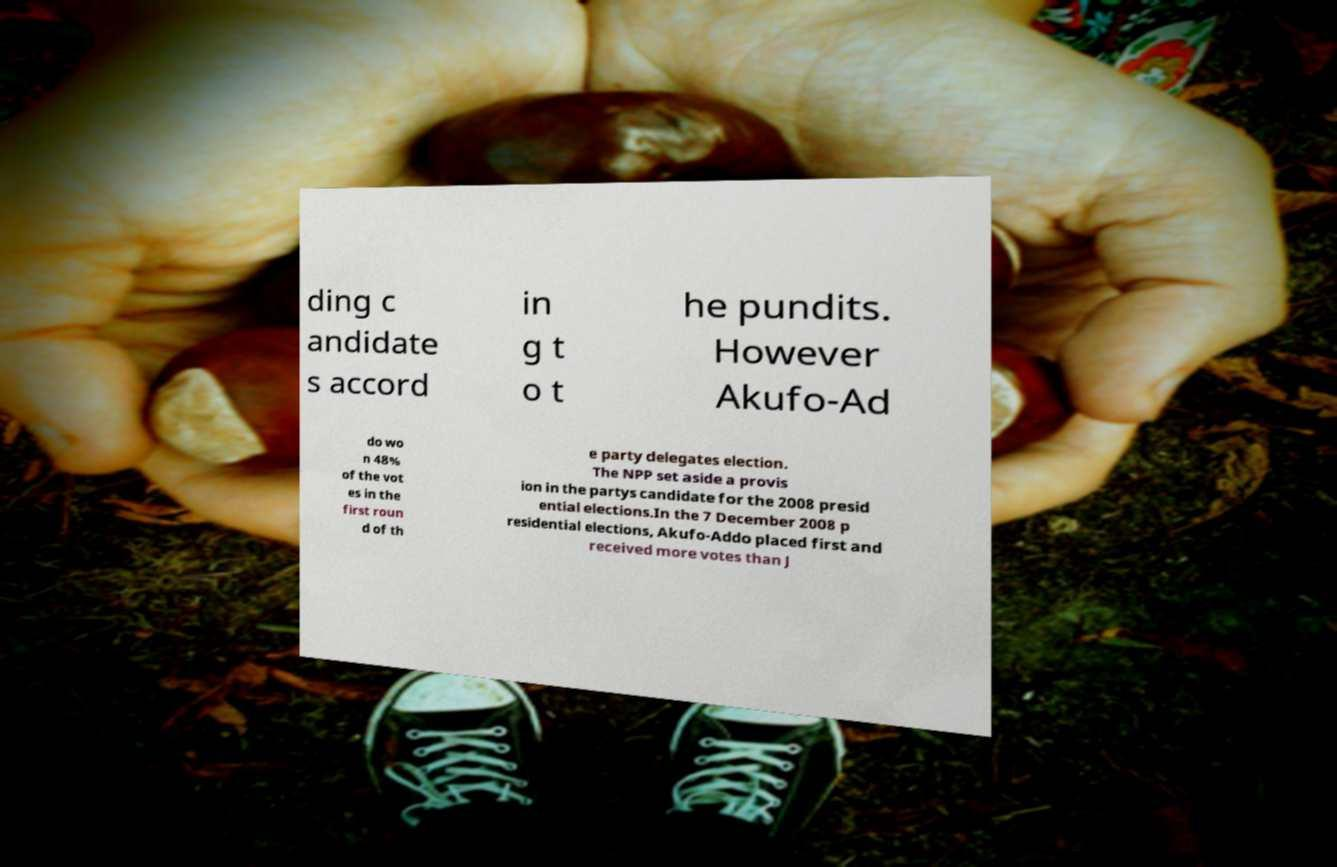For documentation purposes, I need the text within this image transcribed. Could you provide that? ding c andidate s accord in g t o t he pundits. However Akufo-Ad do wo n 48% of the vot es in the first roun d of th e party delegates election. The NPP set aside a provis ion in the partys candidate for the 2008 presid ential elections.In the 7 December 2008 p residential elections, Akufo-Addo placed first and received more votes than J 